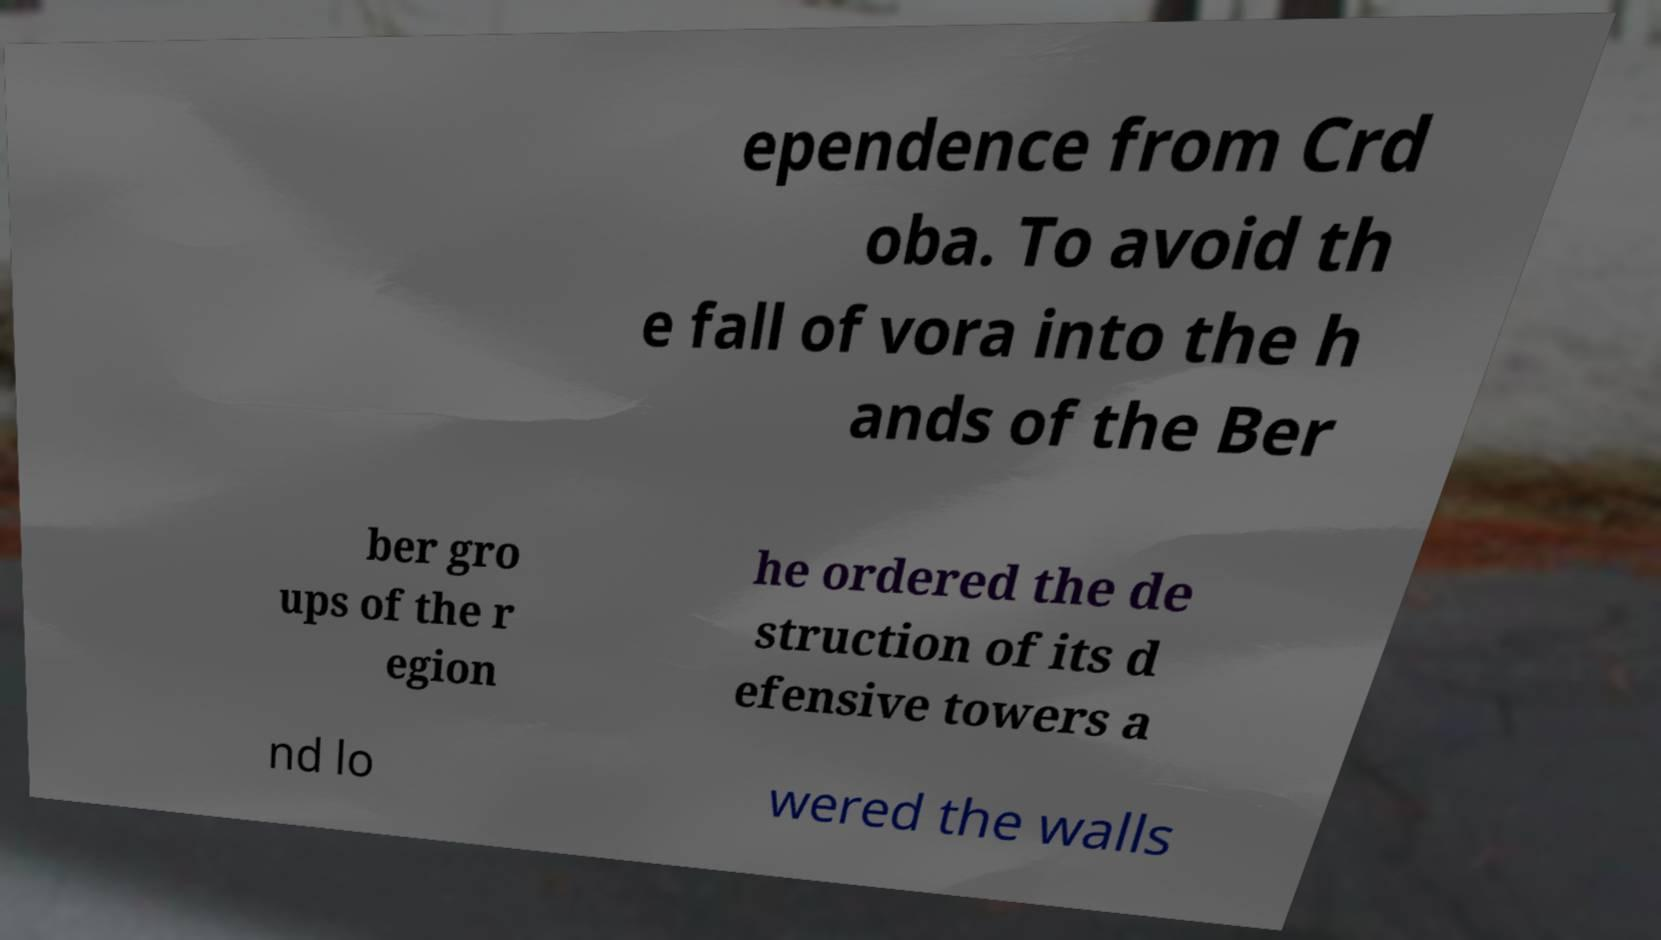Please identify and transcribe the text found in this image. ependence from Crd oba. To avoid th e fall of vora into the h ands of the Ber ber gro ups of the r egion he ordered the de struction of its d efensive towers a nd lo wered the walls 